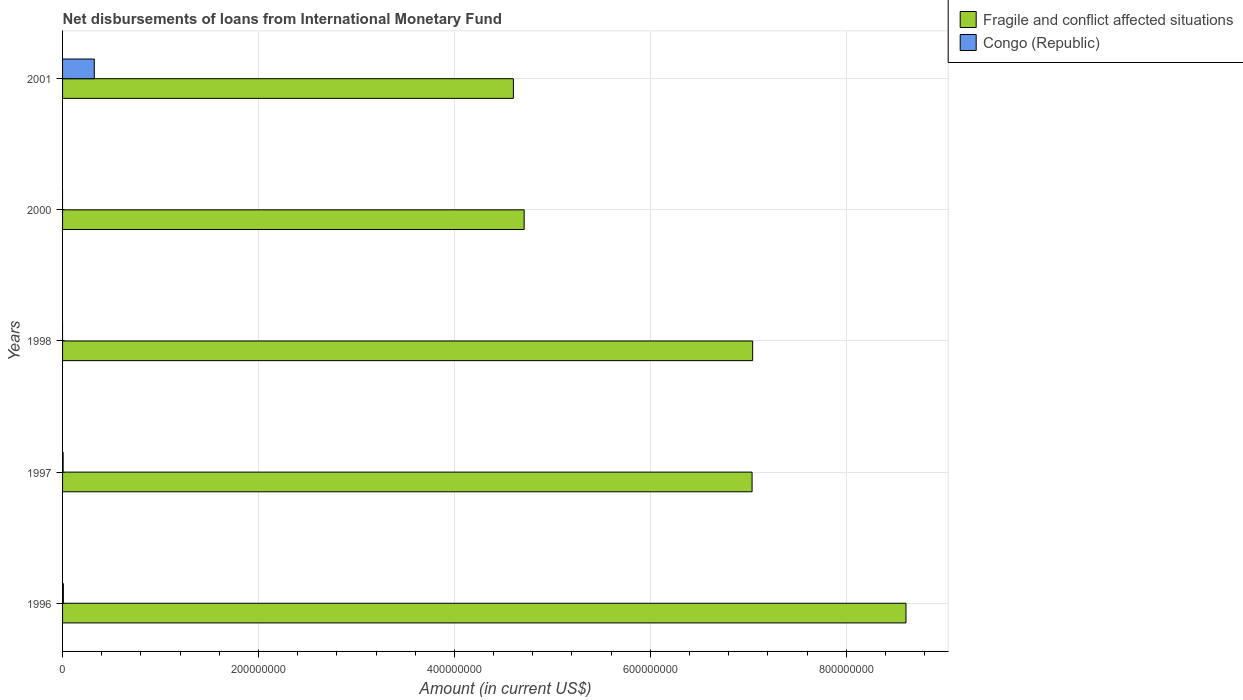How many different coloured bars are there?
Your response must be concise. 2. Are the number of bars per tick equal to the number of legend labels?
Offer a terse response. No. How many bars are there on the 3rd tick from the top?
Your answer should be compact. 1. How many bars are there on the 1st tick from the bottom?
Give a very brief answer. 2. In how many cases, is the number of bars for a given year not equal to the number of legend labels?
Your response must be concise. 2. What is the amount of loans disbursed in Fragile and conflict affected situations in 1997?
Offer a very short reply. 7.04e+08. Across all years, what is the maximum amount of loans disbursed in Congo (Republic)?
Offer a terse response. 3.24e+07. Across all years, what is the minimum amount of loans disbursed in Fragile and conflict affected situations?
Provide a succinct answer. 4.60e+08. What is the total amount of loans disbursed in Congo (Republic) in the graph?
Your response must be concise. 3.38e+07. What is the difference between the amount of loans disbursed in Fragile and conflict affected situations in 1998 and that in 2000?
Offer a terse response. 2.33e+08. What is the difference between the amount of loans disbursed in Congo (Republic) in 1997 and the amount of loans disbursed in Fragile and conflict affected situations in 1998?
Your answer should be very brief. -7.04e+08. What is the average amount of loans disbursed in Congo (Republic) per year?
Provide a short and direct response. 6.76e+06. In the year 1997, what is the difference between the amount of loans disbursed in Fragile and conflict affected situations and amount of loans disbursed in Congo (Republic)?
Your response must be concise. 7.03e+08. In how many years, is the amount of loans disbursed in Fragile and conflict affected situations greater than 280000000 US$?
Your response must be concise. 5. What is the ratio of the amount of loans disbursed in Fragile and conflict affected situations in 1997 to that in 1998?
Provide a succinct answer. 1. What is the difference between the highest and the second highest amount of loans disbursed in Congo (Republic)?
Provide a succinct answer. 3.16e+07. What is the difference between the highest and the lowest amount of loans disbursed in Fragile and conflict affected situations?
Make the answer very short. 4.01e+08. Are all the bars in the graph horizontal?
Your answer should be very brief. Yes. How many years are there in the graph?
Your response must be concise. 5. What is the difference between two consecutive major ticks on the X-axis?
Keep it short and to the point. 2.00e+08. Does the graph contain grids?
Give a very brief answer. Yes. What is the title of the graph?
Provide a short and direct response. Net disbursements of loans from International Monetary Fund. What is the Amount (in current US$) of Fragile and conflict affected situations in 1996?
Provide a short and direct response. 8.61e+08. What is the Amount (in current US$) of Congo (Republic) in 1996?
Ensure brevity in your answer.  8.24e+05. What is the Amount (in current US$) of Fragile and conflict affected situations in 1997?
Ensure brevity in your answer.  7.04e+08. What is the Amount (in current US$) of Congo (Republic) in 1997?
Give a very brief answer. 5.89e+05. What is the Amount (in current US$) of Fragile and conflict affected situations in 1998?
Provide a succinct answer. 7.05e+08. What is the Amount (in current US$) of Fragile and conflict affected situations in 2000?
Keep it short and to the point. 4.71e+08. What is the Amount (in current US$) of Fragile and conflict affected situations in 2001?
Your answer should be very brief. 4.60e+08. What is the Amount (in current US$) of Congo (Republic) in 2001?
Your answer should be very brief. 3.24e+07. Across all years, what is the maximum Amount (in current US$) in Fragile and conflict affected situations?
Offer a very short reply. 8.61e+08. Across all years, what is the maximum Amount (in current US$) in Congo (Republic)?
Keep it short and to the point. 3.24e+07. Across all years, what is the minimum Amount (in current US$) of Fragile and conflict affected situations?
Your response must be concise. 4.60e+08. Across all years, what is the minimum Amount (in current US$) of Congo (Republic)?
Provide a short and direct response. 0. What is the total Amount (in current US$) in Fragile and conflict affected situations in the graph?
Your response must be concise. 3.20e+09. What is the total Amount (in current US$) of Congo (Republic) in the graph?
Offer a very short reply. 3.38e+07. What is the difference between the Amount (in current US$) of Fragile and conflict affected situations in 1996 and that in 1997?
Ensure brevity in your answer.  1.57e+08. What is the difference between the Amount (in current US$) in Congo (Republic) in 1996 and that in 1997?
Offer a terse response. 2.35e+05. What is the difference between the Amount (in current US$) in Fragile and conflict affected situations in 1996 and that in 1998?
Make the answer very short. 1.57e+08. What is the difference between the Amount (in current US$) of Fragile and conflict affected situations in 1996 and that in 2000?
Ensure brevity in your answer.  3.90e+08. What is the difference between the Amount (in current US$) in Fragile and conflict affected situations in 1996 and that in 2001?
Ensure brevity in your answer.  4.01e+08. What is the difference between the Amount (in current US$) in Congo (Republic) in 1996 and that in 2001?
Keep it short and to the point. -3.16e+07. What is the difference between the Amount (in current US$) of Fragile and conflict affected situations in 1997 and that in 1998?
Offer a terse response. -5.97e+05. What is the difference between the Amount (in current US$) in Fragile and conflict affected situations in 1997 and that in 2000?
Give a very brief answer. 2.33e+08. What is the difference between the Amount (in current US$) of Fragile and conflict affected situations in 1997 and that in 2001?
Make the answer very short. 2.44e+08. What is the difference between the Amount (in current US$) in Congo (Republic) in 1997 and that in 2001?
Provide a succinct answer. -3.18e+07. What is the difference between the Amount (in current US$) of Fragile and conflict affected situations in 1998 and that in 2000?
Your response must be concise. 2.33e+08. What is the difference between the Amount (in current US$) of Fragile and conflict affected situations in 1998 and that in 2001?
Your answer should be compact. 2.44e+08. What is the difference between the Amount (in current US$) in Fragile and conflict affected situations in 2000 and that in 2001?
Provide a succinct answer. 1.10e+07. What is the difference between the Amount (in current US$) in Fragile and conflict affected situations in 1996 and the Amount (in current US$) in Congo (Republic) in 1997?
Your answer should be very brief. 8.60e+08. What is the difference between the Amount (in current US$) in Fragile and conflict affected situations in 1996 and the Amount (in current US$) in Congo (Republic) in 2001?
Provide a succinct answer. 8.29e+08. What is the difference between the Amount (in current US$) of Fragile and conflict affected situations in 1997 and the Amount (in current US$) of Congo (Republic) in 2001?
Provide a short and direct response. 6.72e+08. What is the difference between the Amount (in current US$) of Fragile and conflict affected situations in 1998 and the Amount (in current US$) of Congo (Republic) in 2001?
Ensure brevity in your answer.  6.72e+08. What is the difference between the Amount (in current US$) in Fragile and conflict affected situations in 2000 and the Amount (in current US$) in Congo (Republic) in 2001?
Keep it short and to the point. 4.39e+08. What is the average Amount (in current US$) of Fragile and conflict affected situations per year?
Ensure brevity in your answer.  6.40e+08. What is the average Amount (in current US$) in Congo (Republic) per year?
Make the answer very short. 6.76e+06. In the year 1996, what is the difference between the Amount (in current US$) of Fragile and conflict affected situations and Amount (in current US$) of Congo (Republic)?
Make the answer very short. 8.60e+08. In the year 1997, what is the difference between the Amount (in current US$) of Fragile and conflict affected situations and Amount (in current US$) of Congo (Republic)?
Your answer should be compact. 7.03e+08. In the year 2001, what is the difference between the Amount (in current US$) of Fragile and conflict affected situations and Amount (in current US$) of Congo (Republic)?
Provide a succinct answer. 4.28e+08. What is the ratio of the Amount (in current US$) of Fragile and conflict affected situations in 1996 to that in 1997?
Your answer should be very brief. 1.22. What is the ratio of the Amount (in current US$) in Congo (Republic) in 1996 to that in 1997?
Offer a terse response. 1.4. What is the ratio of the Amount (in current US$) in Fragile and conflict affected situations in 1996 to that in 1998?
Keep it short and to the point. 1.22. What is the ratio of the Amount (in current US$) of Fragile and conflict affected situations in 1996 to that in 2000?
Make the answer very short. 1.83. What is the ratio of the Amount (in current US$) of Fragile and conflict affected situations in 1996 to that in 2001?
Your answer should be very brief. 1.87. What is the ratio of the Amount (in current US$) of Congo (Republic) in 1996 to that in 2001?
Your answer should be very brief. 0.03. What is the ratio of the Amount (in current US$) in Fragile and conflict affected situations in 1997 to that in 2000?
Your answer should be very brief. 1.49. What is the ratio of the Amount (in current US$) in Fragile and conflict affected situations in 1997 to that in 2001?
Offer a terse response. 1.53. What is the ratio of the Amount (in current US$) of Congo (Republic) in 1997 to that in 2001?
Give a very brief answer. 0.02. What is the ratio of the Amount (in current US$) in Fragile and conflict affected situations in 1998 to that in 2000?
Keep it short and to the point. 1.5. What is the ratio of the Amount (in current US$) in Fragile and conflict affected situations in 1998 to that in 2001?
Ensure brevity in your answer.  1.53. What is the ratio of the Amount (in current US$) in Fragile and conflict affected situations in 2000 to that in 2001?
Ensure brevity in your answer.  1.02. What is the difference between the highest and the second highest Amount (in current US$) in Fragile and conflict affected situations?
Keep it short and to the point. 1.57e+08. What is the difference between the highest and the second highest Amount (in current US$) in Congo (Republic)?
Offer a terse response. 3.16e+07. What is the difference between the highest and the lowest Amount (in current US$) of Fragile and conflict affected situations?
Give a very brief answer. 4.01e+08. What is the difference between the highest and the lowest Amount (in current US$) of Congo (Republic)?
Make the answer very short. 3.24e+07. 